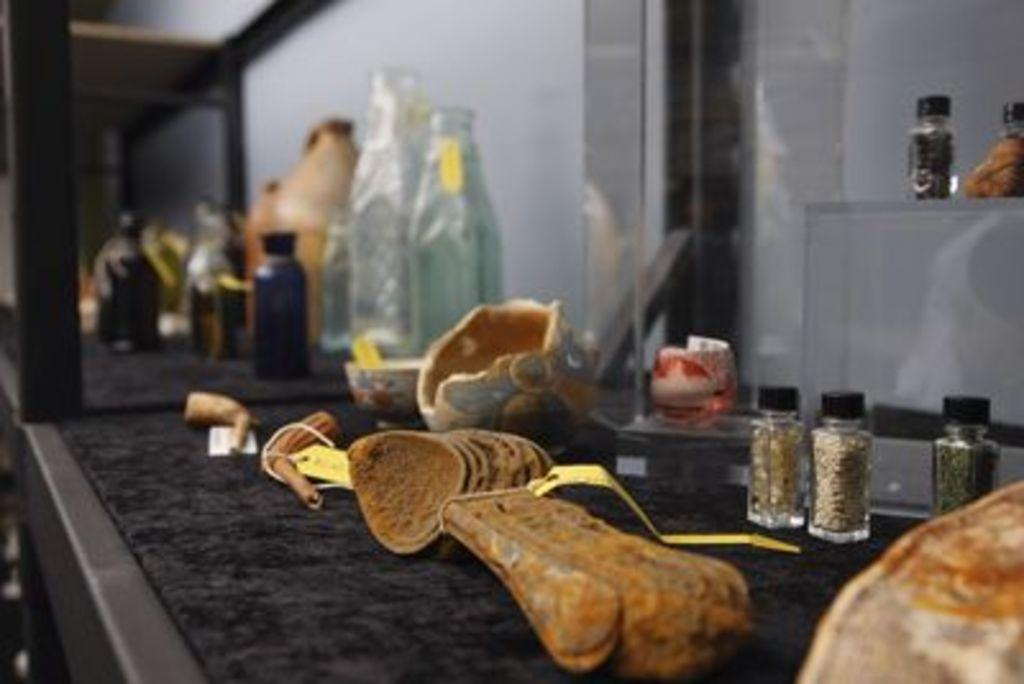What is located at the bottom of the image? There is a shelf at the bottom of the image. What can be seen on the shelf? There are bottles and spoons on the shelf, as well as other objects. What is visible in the background of the image? There is a wall in the background of the image. What type of punishment is being administered in the image? There is no punishment being administered in the image; it only shows a shelf with bottles, spoons, and other objects. What design elements can be seen in the thread used in the image? There is no thread present in the image. 